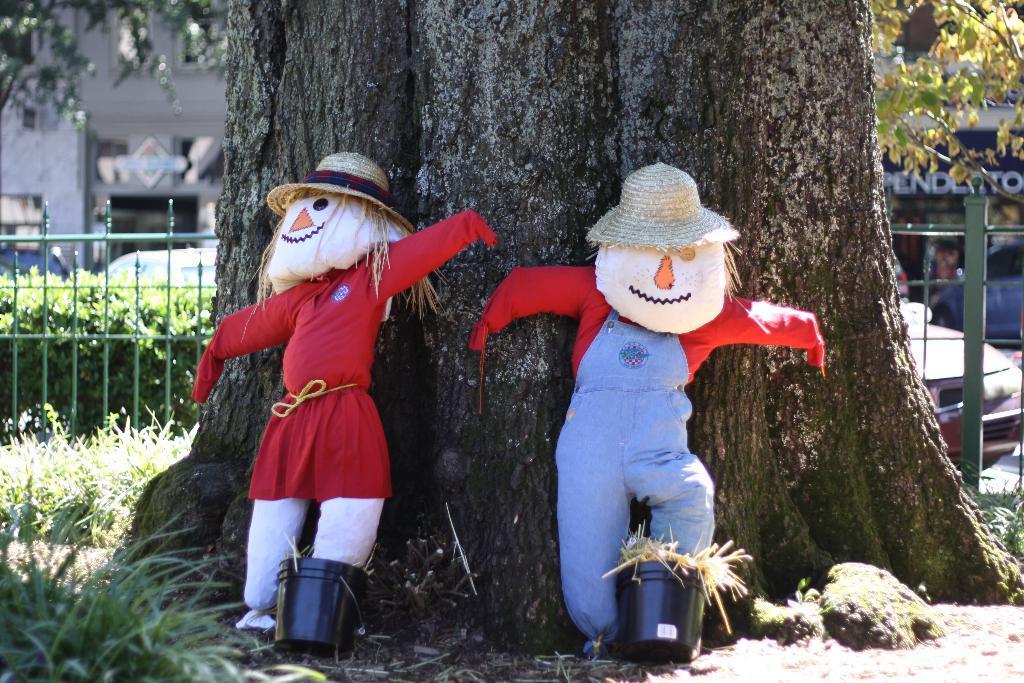Could you give a brief overview of what you see in this image? In this picture I can observe two scarecrows on the land. Behind the scarecrows there is a tree. I can observe green color railing on the left side. There are some plants and grass on the ground. In the background there are some cars on the road. 